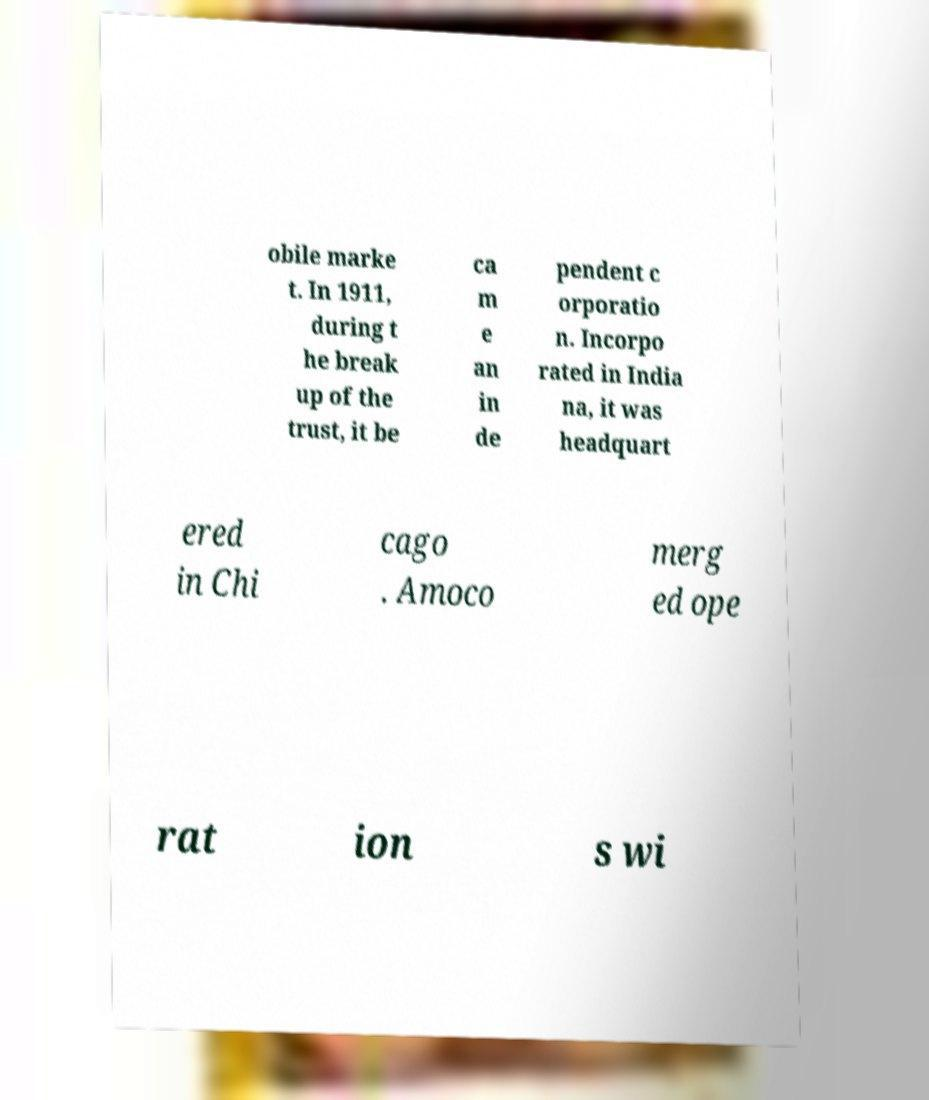Could you extract and type out the text from this image? obile marke t. In 1911, during t he break up of the trust, it be ca m e an in de pendent c orporatio n. Incorpo rated in India na, it was headquart ered in Chi cago . Amoco merg ed ope rat ion s wi 